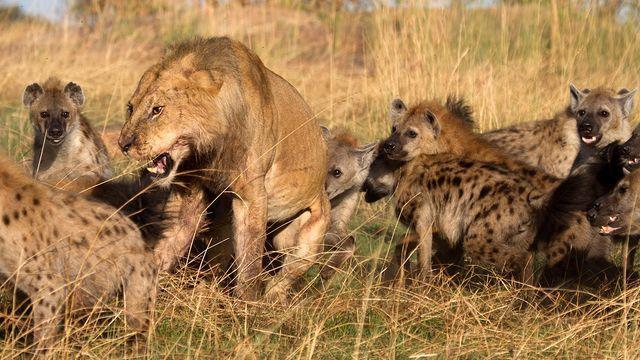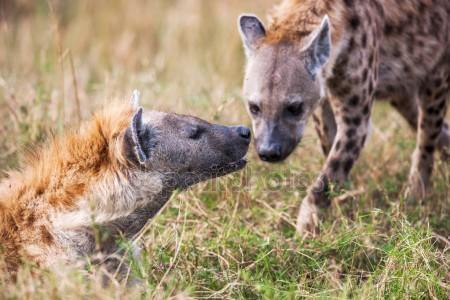The first image is the image on the left, the second image is the image on the right. Assess this claim about the two images: "There are two hyenas in one of the images, and a lion near one or more hyenas in the other.". Correct or not? Answer yes or no. Yes. The first image is the image on the left, the second image is the image on the right. Evaluate the accuracy of this statement regarding the images: "An image shows an open-mouthed lion next to at least one hyena.". Is it true? Answer yes or no. Yes. 